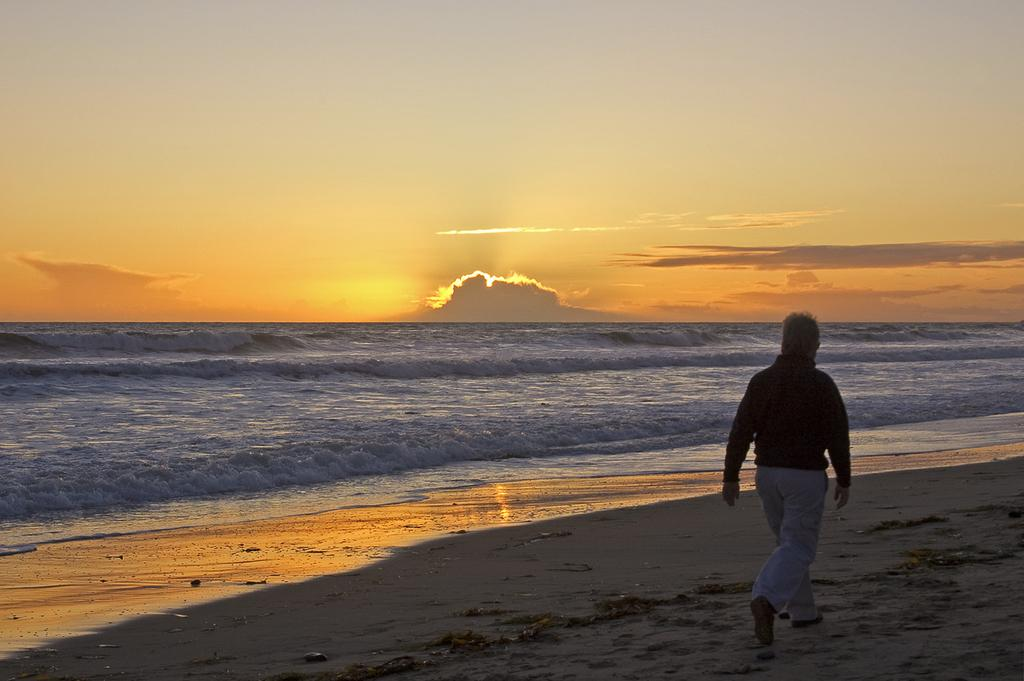What is the main subject of the image? There is a man standing in the image. What is the man wearing? The man is wearing white pants. What can be seen in the background of the image? There is water visible in the image, and there are clouds in the sky. What part of the natural environment is visible in the image? The sky is visible in the image. What type of design can be seen on the shelf in the image? There is no shelf present in the image, so it is not possible to determine the design. 